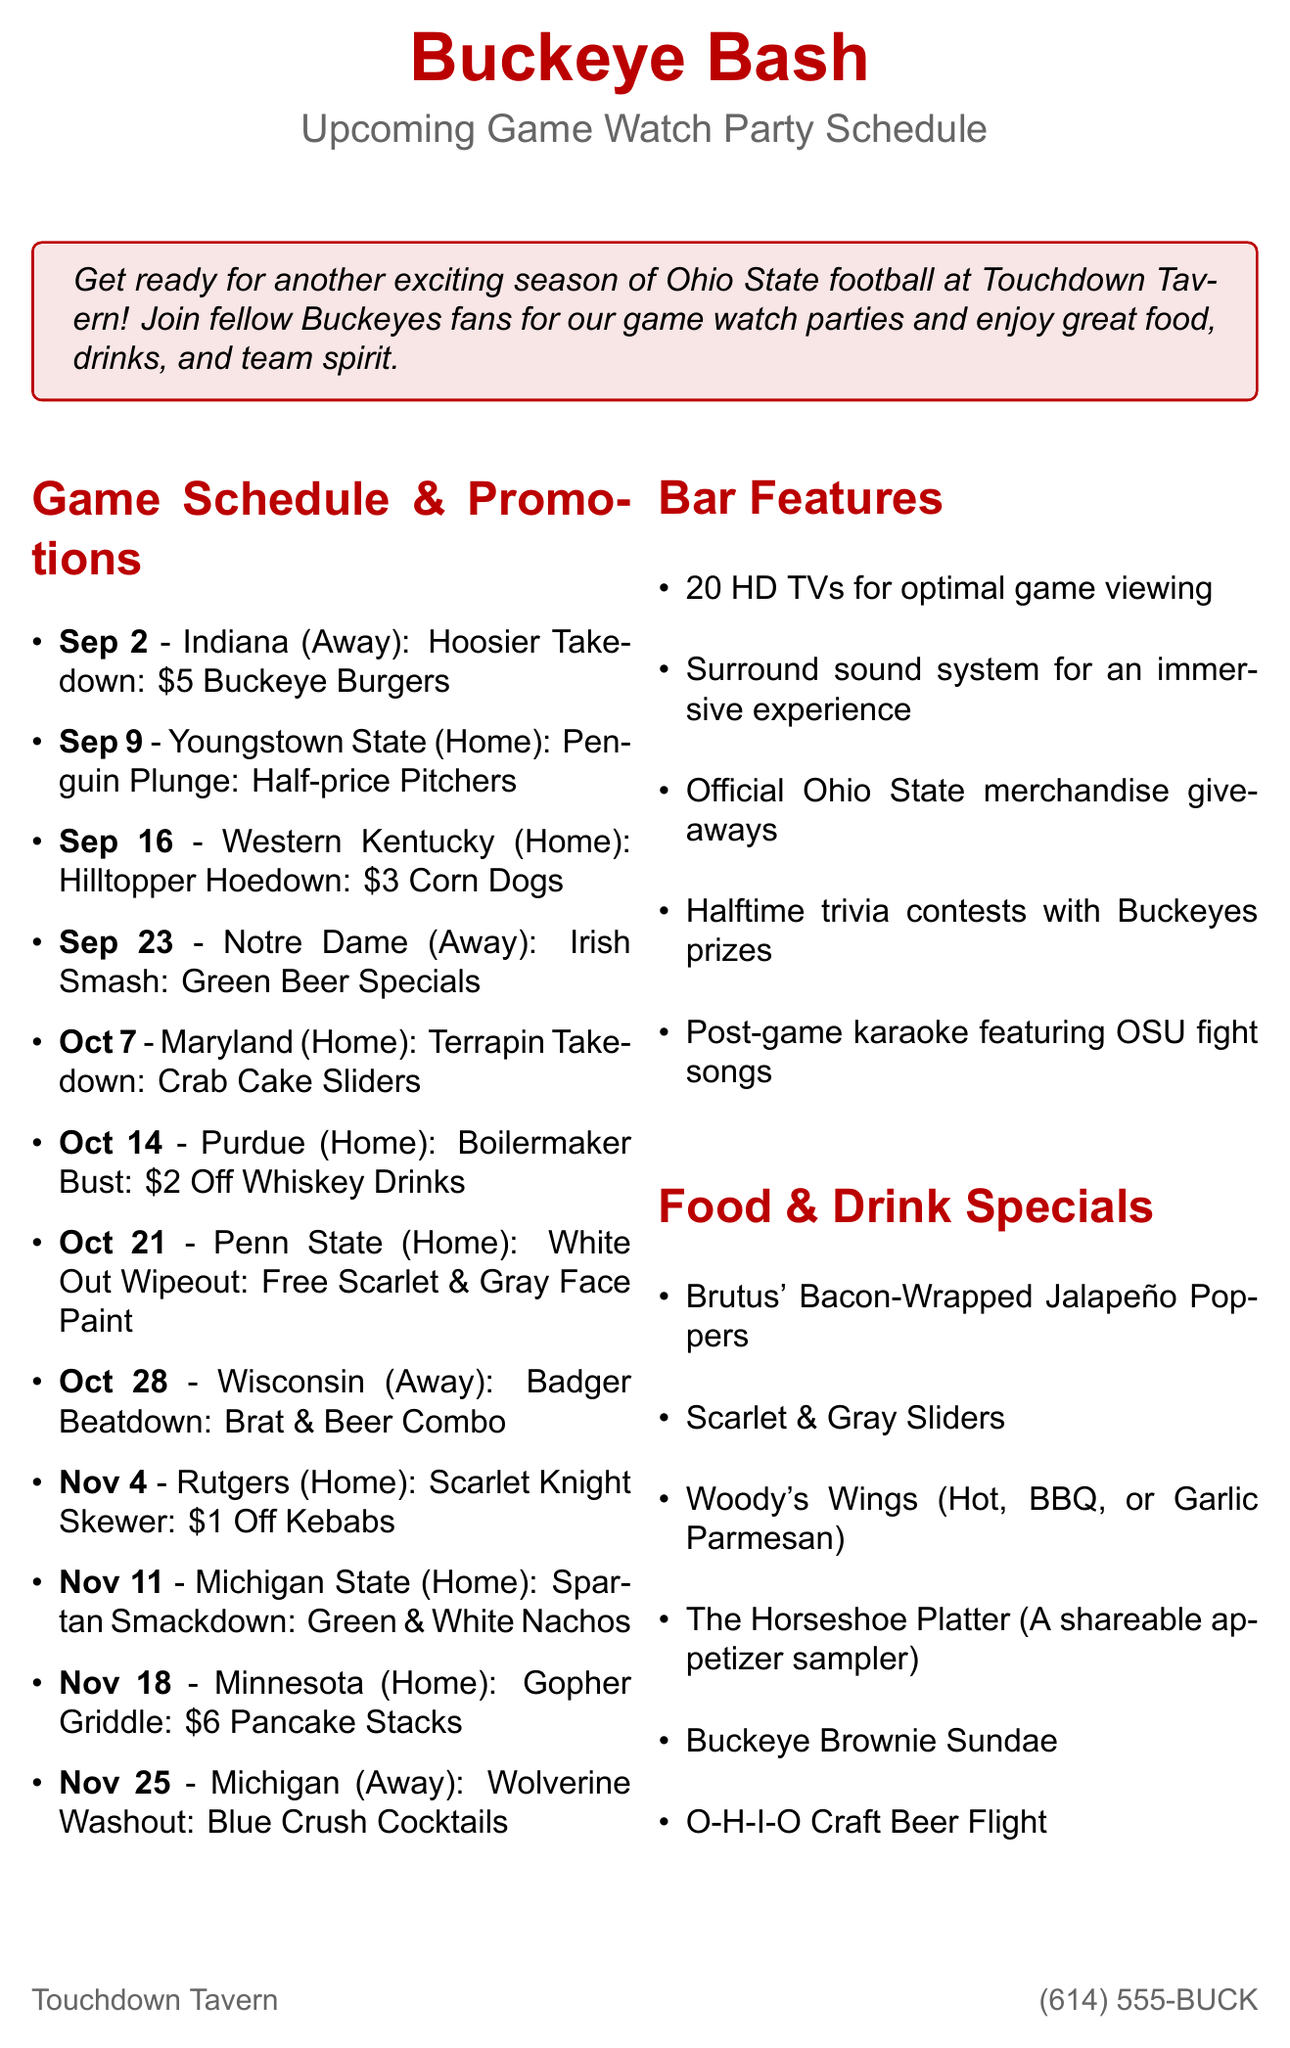What is the date of the game against Indiana? The game against Indiana is scheduled for September 2, 2023.
Answer: September 2, 2023 What is the special promotion for the game on September 16? The special promotion for the game on September 16 against Western Kentucky is $3 Corn Dogs.
Answer: $3 Corn Dogs How many HD TVs does Touchdown Tavern have? The document states that there are 20 HD TVs for optimal game viewing.
Answer: 20 What is the name of the loyalty program? The loyalty program mentioned in the document is called Buckeye Fan Rewards.
Answer: Buckeye Fan Rewards What food item is featured on October 14 for the Purdue game? On October 14, for the Purdue game, the featured food item is $2 Off Whiskey Drinks.
Answer: $2 Off Whiskey Drinks How many home games are listed in the schedule? The schedule lists a total of seven home games throughout the season.
Answer: 7 What is offered for free on the first visit to the bar? The bar offers a free appetizer on your first visit as a signup bonus for the loyalty program.
Answer: Free appetizer What kind of beer specials are available during the game against Notre Dame? The special for the Notre Dame game on September 23 includes Green Beer Specials.
Answer: Green Beer Specials What is the contact email for Touchdown Tavern? The contact email for Touchdown Tavern is provided as info@touchdowntavern.com.
Answer: info@touchdowntavern.com 